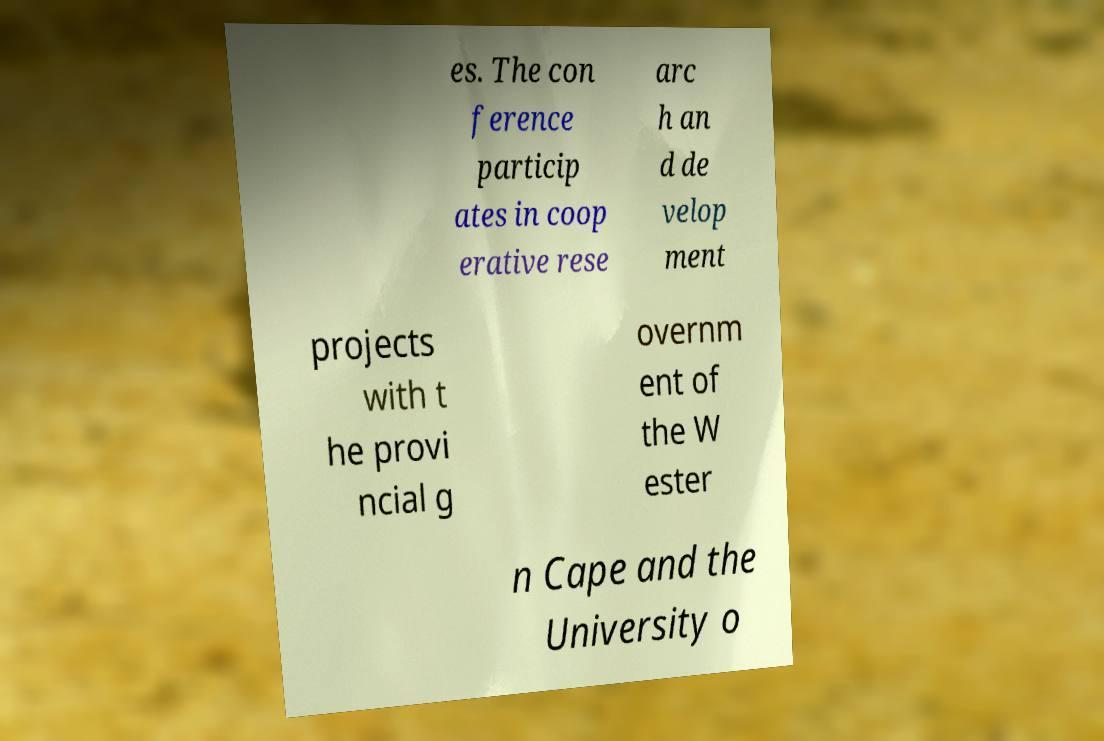What messages or text are displayed in this image? I need them in a readable, typed format. es. The con ference particip ates in coop erative rese arc h an d de velop ment projects with t he provi ncial g overnm ent of the W ester n Cape and the University o 